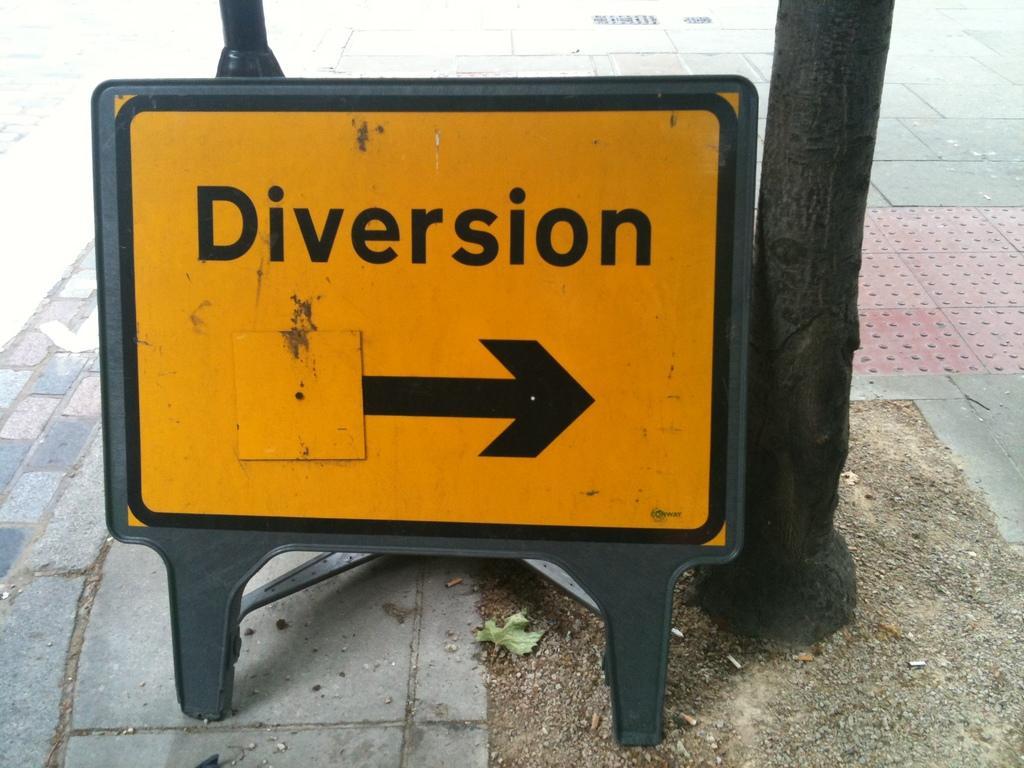In one or two sentences, can you explain what this image depicts? In this image we can see a sign board on the floor. 